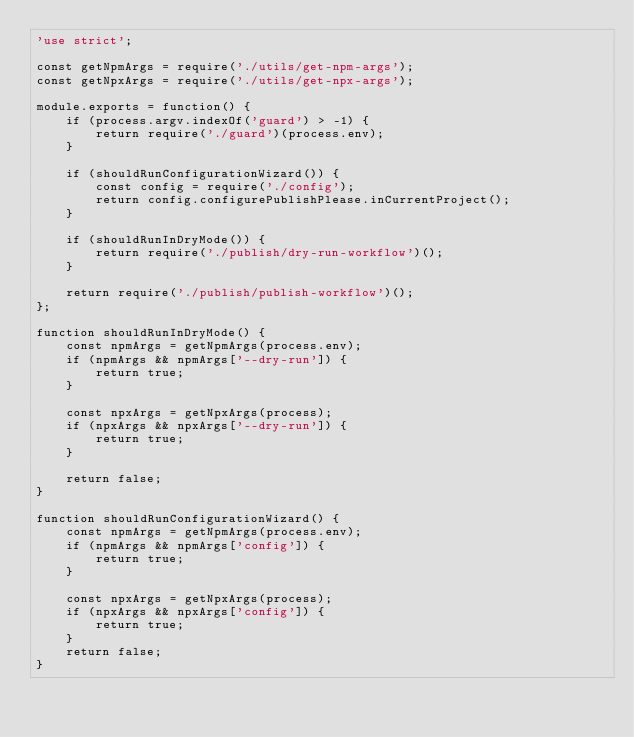Convert code to text. <code><loc_0><loc_0><loc_500><loc_500><_JavaScript_>'use strict';

const getNpmArgs = require('./utils/get-npm-args');
const getNpxArgs = require('./utils/get-npx-args');

module.exports = function() {
    if (process.argv.indexOf('guard') > -1) {
        return require('./guard')(process.env);
    }

    if (shouldRunConfigurationWizard()) {
        const config = require('./config');
        return config.configurePublishPlease.inCurrentProject();
    }

    if (shouldRunInDryMode()) {
        return require('./publish/dry-run-workflow')();
    }

    return require('./publish/publish-workflow')();
};

function shouldRunInDryMode() {
    const npmArgs = getNpmArgs(process.env);
    if (npmArgs && npmArgs['--dry-run']) {
        return true;
    }

    const npxArgs = getNpxArgs(process);
    if (npxArgs && npxArgs['--dry-run']) {
        return true;
    }

    return false;
}

function shouldRunConfigurationWizard() {
    const npmArgs = getNpmArgs(process.env);
    if (npmArgs && npmArgs['config']) {
        return true;
    }

    const npxArgs = getNpxArgs(process);
    if (npxArgs && npxArgs['config']) {
        return true;
    }
    return false;
}
</code> 